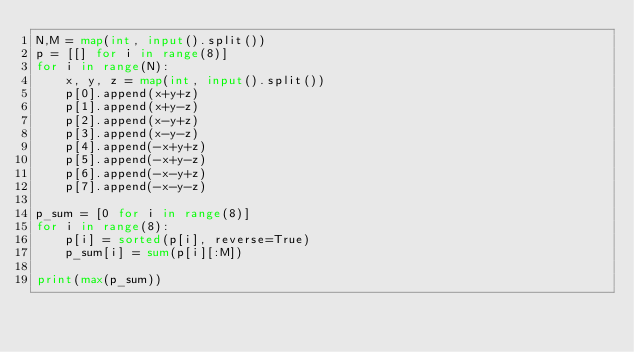Convert code to text. <code><loc_0><loc_0><loc_500><loc_500><_Python_>N,M = map(int, input().split())
p = [[] for i in range(8)]
for i in range(N):
    x, y, z = map(int, input().split())
    p[0].append(x+y+z)
    p[1].append(x+y-z)
    p[2].append(x-y+z)
    p[3].append(x-y-z)
    p[4].append(-x+y+z)
    p[5].append(-x+y-z)
    p[6].append(-x-y+z)
    p[7].append(-x-y-z)

p_sum = [0 for i in range(8)]
for i in range(8):
    p[i] = sorted(p[i], reverse=True)
    p_sum[i] = sum(p[i][:M])

print(max(p_sum))</code> 